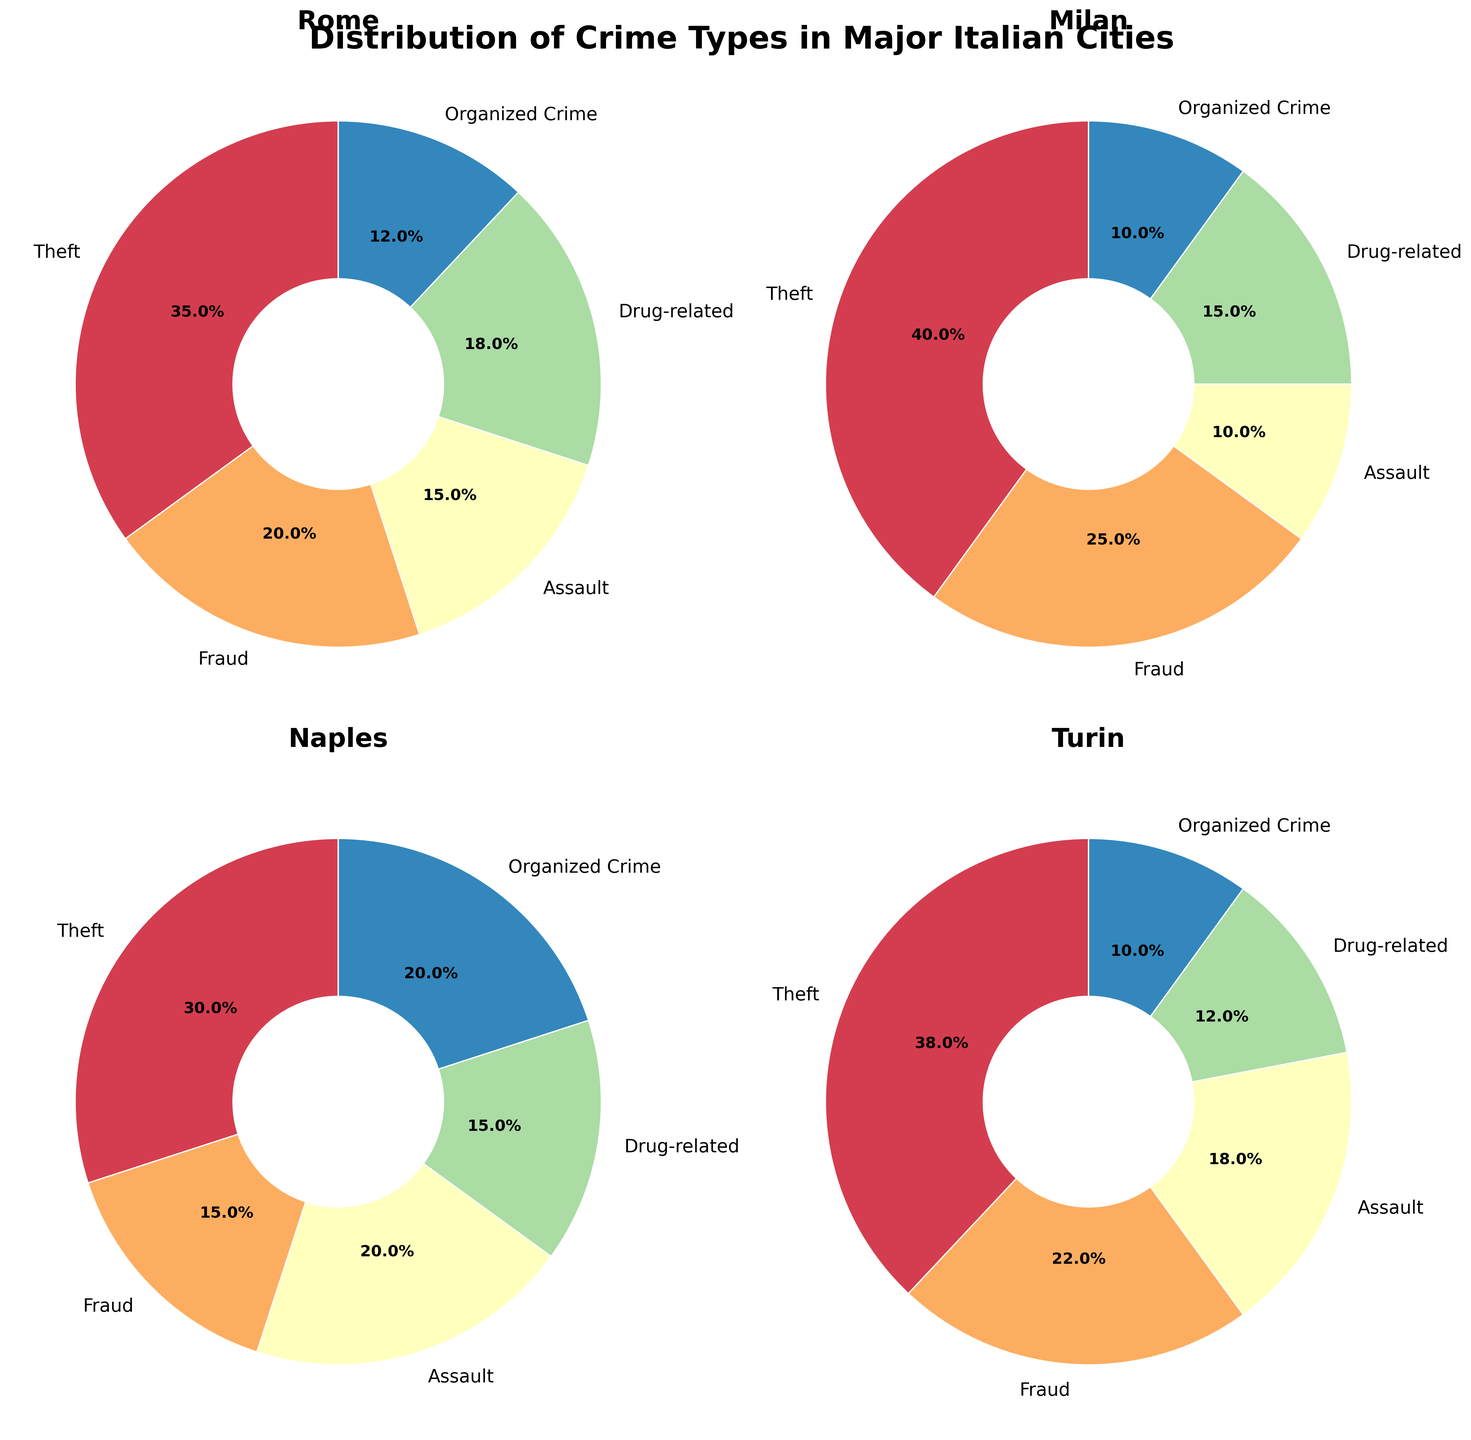Which city has the highest percentage of theft? According to the figure, Milan has the highest percentage of theft at 40%, as visible in the pie chart for Milan.
Answer: Milan What are the top two crime types in Turin? By looking at the percentages in the pie chart for Turin, the top two crime types are Theft at 38% and Fraud at 22%.
Answer: Theft and Fraud Which city shows an equal percentage for Drug-related and Assault crimes? In the pie chart for Naples, Drug-related and Assault crimes both have a percentage of 15%.
Answer: Naples How much higher is the percentage of theft in Milan compared to Naples? The Theft percentage in Milan is 40%, while in Naples it is 30%. The difference is 40% - 30% = 10%.
Answer: 10% What's the combined percentage of organized crime in Rome and Milan? Rome has 12% organized crime and Milan has 10%. The combined percentage is 12% + 10% = 22%.
Answer: 22% Which city has the lowest percentage of fraud? Comparing the pie charts, Naples has the lowest percentage of fraud at 15%.
Answer: Naples Which crime type has the smallest percentage in Rome? By observing the pie chart for Rome, Organized Crime has the smallest percentage at 12%.
Answer: Organized Crime Are there any crime types that have the same percentage across all cities? By comparing the charts, no crime type has exactly the same percentage in all four cities.
Answer: No What percentage of crimes in Naples are drug-related? The pie chart for Naples shows that drug-related crimes constitute 15% of the total crimes.
Answer: 15% Which city has the highest proportion of assault crimes? The pie charts show that Naples has the highest proportion of assault crimes at 20%.
Answer: Naples 